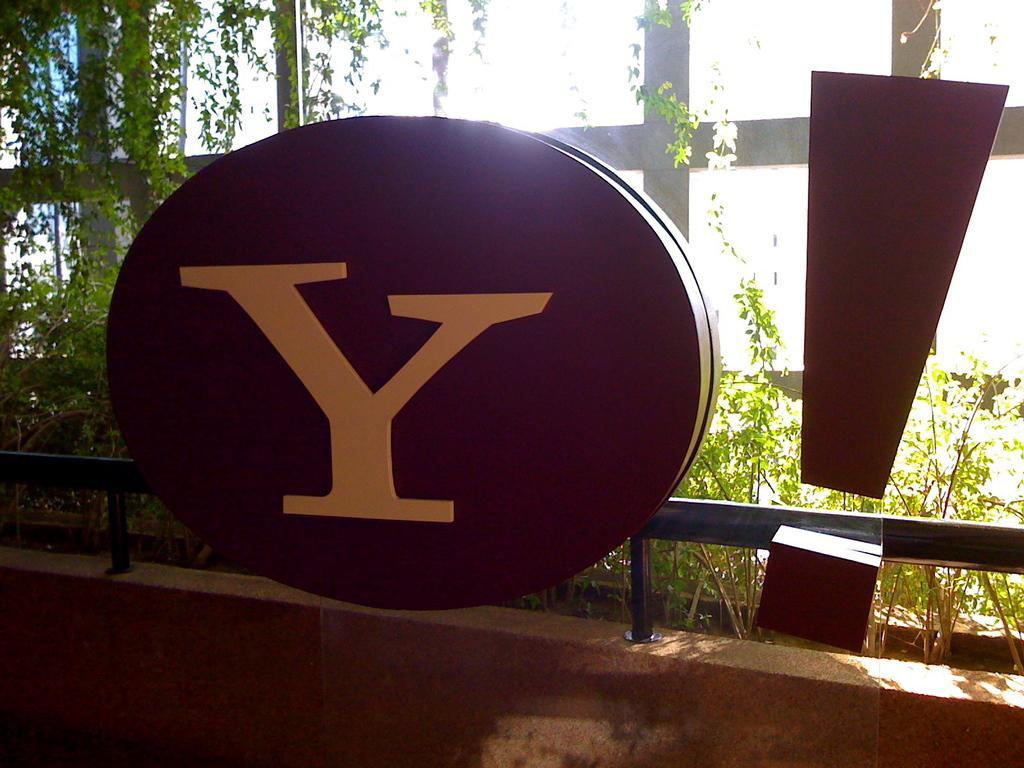What is located in the foreground of the image? There are boards in the foreground of the image. What is written or depicted on one of the boards? There is an alphabet on one of the boards. What can be seen in the background of the image? There are plants visible in the background of the image. What architectural feature is present in the image? There is a railing on a wall in the image. What type of competition is taking place in the image involving dolls and quartz? There is no competition, dolls, or quartz present in the image. 